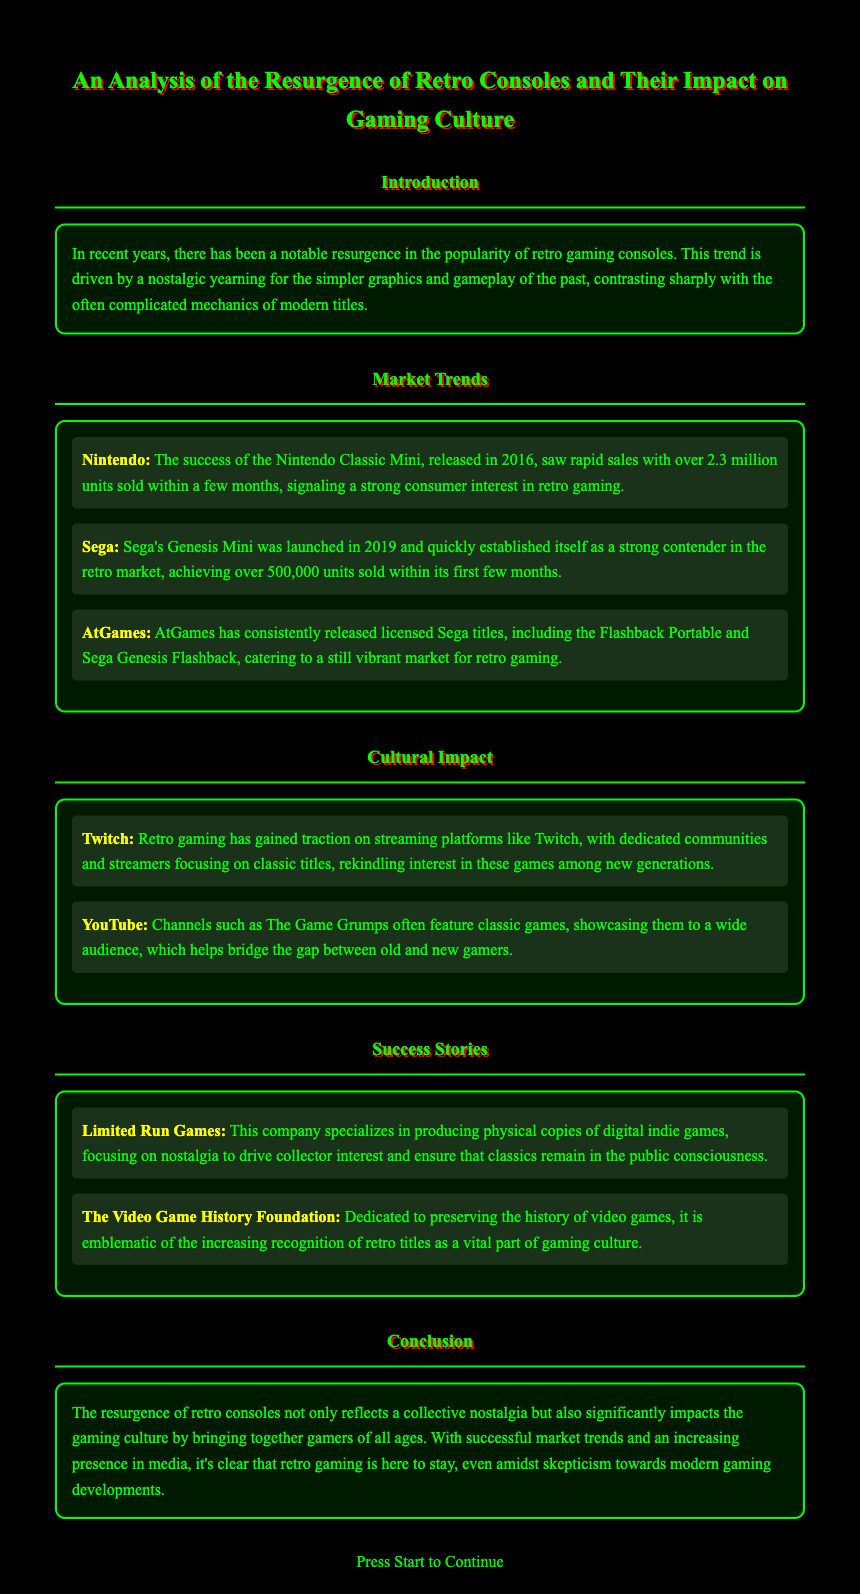What year was the Nintendo Classic Mini released? The document states that the Nintendo Classic Mini was released in 2016.
Answer: 2016 How many units did the Genesis Mini sell in its first few months? The document mentions that Sega's Genesis Mini achieved over 500,000 units sold within its first few months.
Answer: 500,000 Which streaming platform has seen increased interest in retro gaming? The document highlights that Twitch has gained traction for retro gaming.
Answer: Twitch What company specializes in producing physical copies of digital indie games? The document specifies Limited Run Games as the company that focuses on this area.
Answer: Limited Run Games What is a noted function of The Video Game History Foundation? The document describes that the foundation is dedicated to preserving the history of video games.
Answer: Preserving history In what year was the Genesis Mini launched? According to the document, Sega's Genesis Mini was launched in 2019.
Answer: 2019 What gaming culture aspect does the document conclude on? The conclusion mentions that retro gaming brings together gamers of all ages.
Answer: Bringing together gamers How many units were sold by Nintendo Classic Mini shortly after release? The document states that the Nintendo Classic Mini sold over 2.3 million units within a few months.
Answer: 2.3 million 